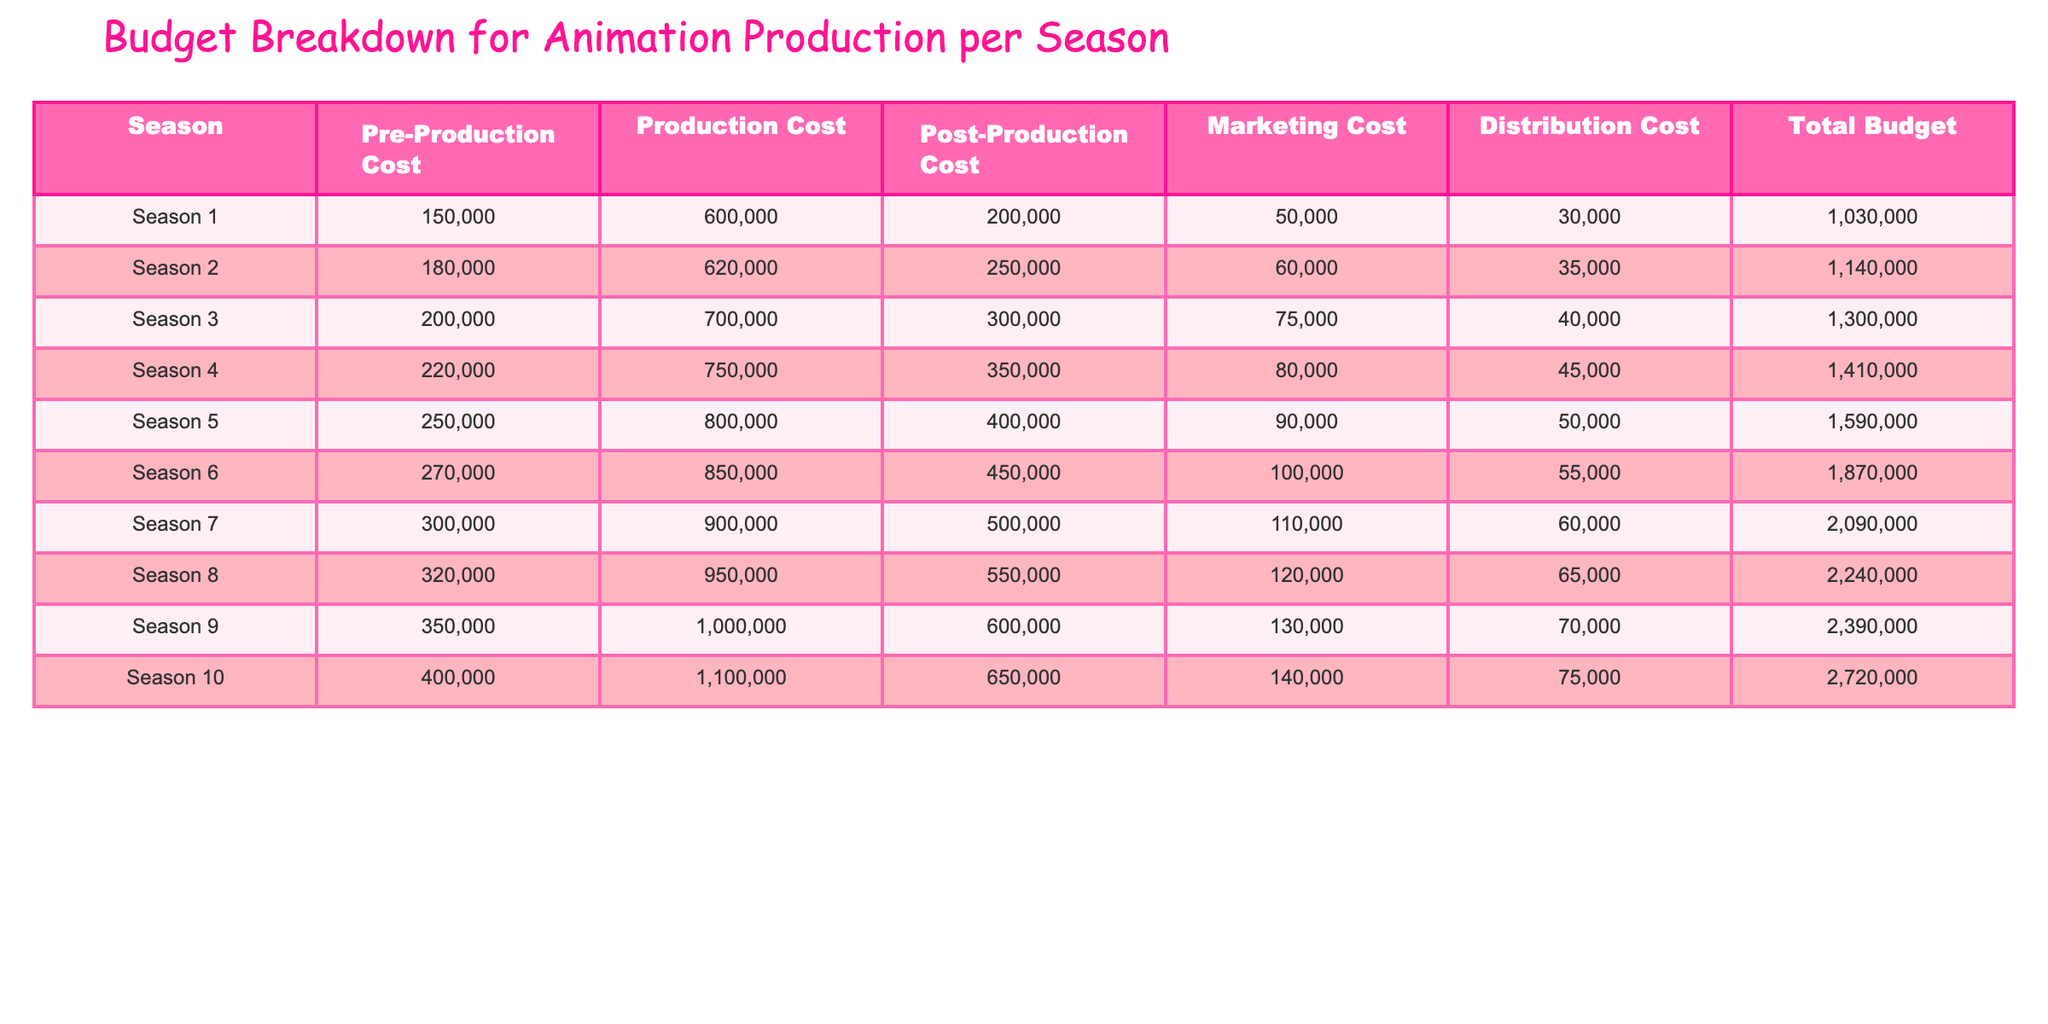What is the total budget for Season 5? In the table, locate Season 5's row, and find the "Total Budget" column. The value listed is 1,590,000.
Answer: 1,590,000 Which season has the highest production cost? Compare the values in the "Production Cost" column across all seasons. Season 10 shows the highest cost of 1,100,000.
Answer: Season 10 What is the difference in total budget between Season 1 and Season 10? Find the total budgets for both seasons: Season 1 has 1,030,000 and Season 10 has 2,720,000. The difference is 2,720,000 - 1,030,000 = 1,690,000.
Answer: 1,690,000 What is the average pre-production cost over all seasons? Add all the pre-production costs: (150,000 + 180,000 + 200,000 + 220,000 + 250,000 + 270,000 + 300,000 + 320,000 + 350,000 + 400,000) = 2,570,000. There are 10 seasons, so the average is 2,570,000 / 10 = 257,000.
Answer: 257,000 Is the marketing cost in Season 7 higher than in Season 3? Look at the marketing costs for both seasons: Season 7 has 110,000 and Season 3 has 75,000. Since 110,000 > 75,000, the statement is true.
Answer: Yes What is the total cost of post-production and distribution for Season 6? For Season 6, find the "Post-Production Cost" (450,000) and "Distribution Cost" (55,000). Their total is 450,000 + 55,000 = 505,000.
Answer: 505,000 How much did the total budget increase from Season 4 to Season 8? Calculate the budgets for both seasons: Season 4 is 1,410,000 and Season 8 is 2,240,000. The increase is 2,240,000 - 1,410,000 = 830,000.
Answer: 830,000 Does the cost of pre-production increase by more than 10% each season? Compare the pre-production costs in sequence: Season 1 (150,000) to Season 2 (180,000); percentage increase = (180,000 - 150,000) / 150,000 = 20%. The same calculation shows increase across all subsequent seasons, thus, all exceed 10%.
Answer: Yes In which season is the post-production cost the lowest? Inspect the "Post-Production Cost" column, Season 1 has the lowest value of 200,000 compared to other seasons.
Answer: Season 1 What is the median marketing cost across all seasons? List the marketing costs in ascending order: 50,000, 60,000, 70,000, 80,000, 90,000, 100,000, 110,000, 120,000, 130,000, 140,000. The median (the average of the 5th and 6th values) is (90,000 + 100,000) / 2 = 95,000.
Answer: 95,000 